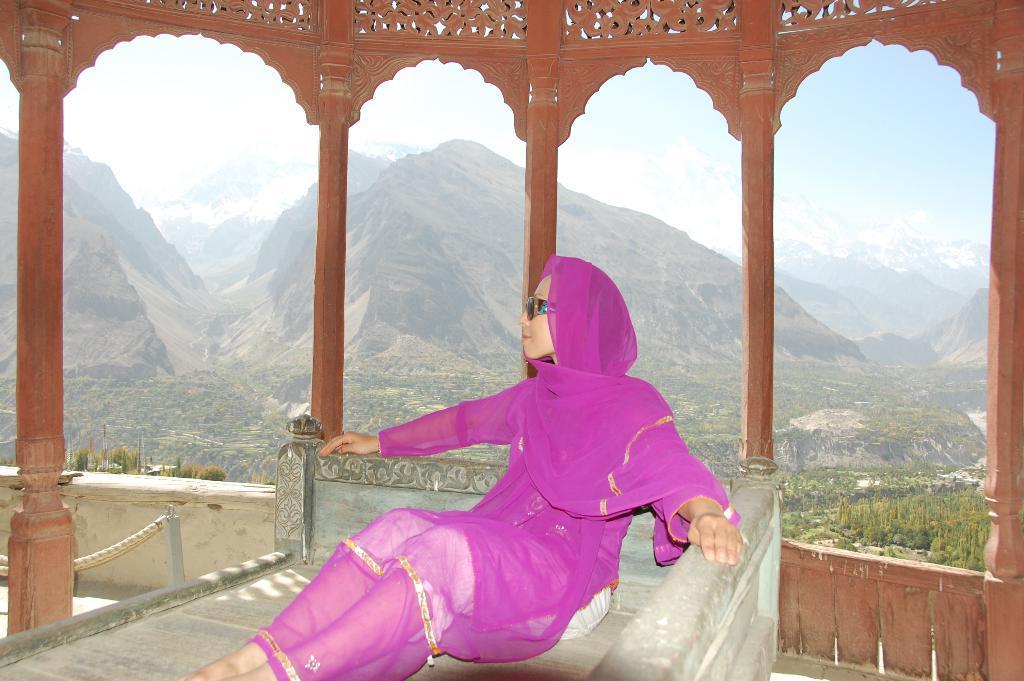In one or two sentences, can you explain what this image depicts? In this image I can see inside view of a building and a woman wearing a pink color dress and sitting on the bed and back side I can see the hill and the sky 